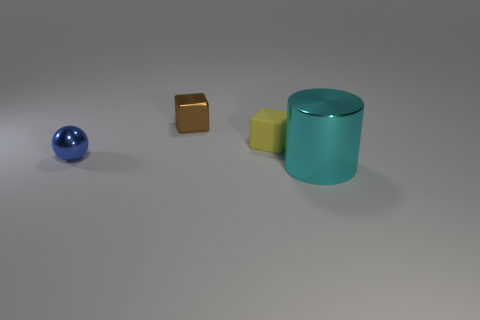Add 3 tiny objects. How many objects exist? 7 Subtract all cylinders. How many objects are left? 3 Subtract all small red rubber objects. Subtract all yellow rubber things. How many objects are left? 3 Add 4 tiny metallic spheres. How many tiny metallic spheres are left? 5 Add 2 cyan rubber objects. How many cyan rubber objects exist? 2 Subtract 1 brown blocks. How many objects are left? 3 